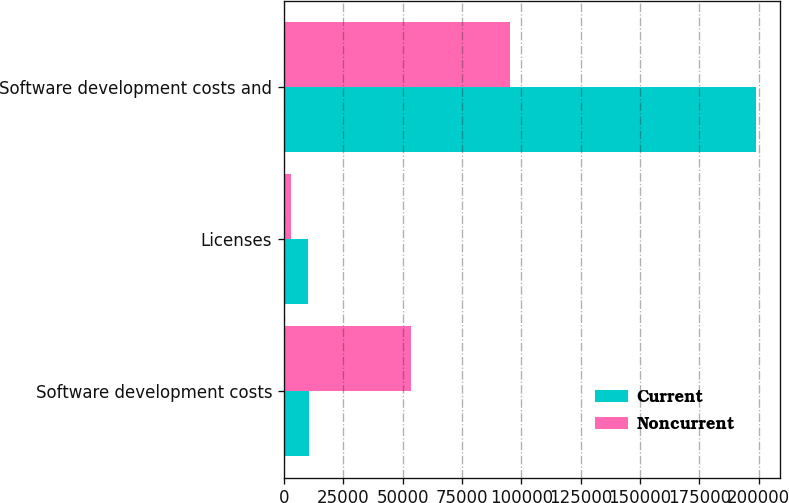Convert chart. <chart><loc_0><loc_0><loc_500><loc_500><stacked_bar_chart><ecel><fcel>Software development costs<fcel>Licenses<fcel>Software development costs and<nl><fcel>Current<fcel>10469<fcel>10189<fcel>198955<nl><fcel>Noncurrent<fcel>53649<fcel>3000<fcel>95241<nl></chart> 